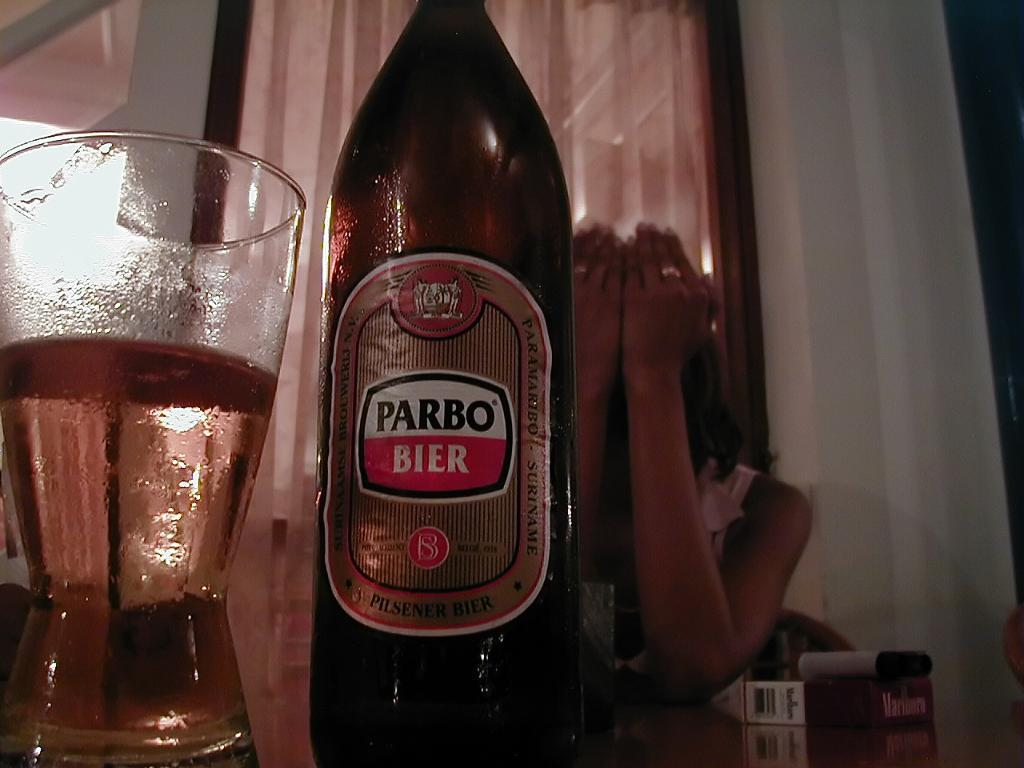<image>
Describe the image concisely. The beer in the bottle is Parbo Bier. 